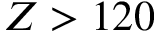<formula> <loc_0><loc_0><loc_500><loc_500>Z > 1 2 0</formula> 